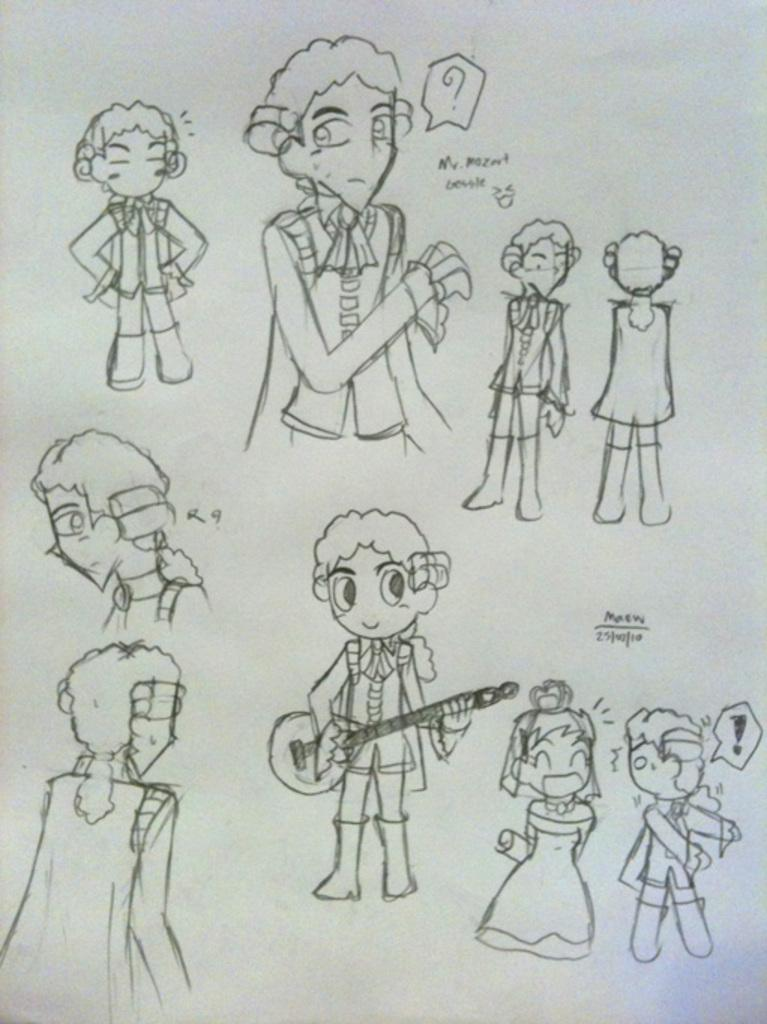What is depicted in the image? There is a drawing of persons in the image. What are the persons in the drawing doing? There is a person holding a musical instrument in the drawing. What else can be seen in the image besides the drawing? There is text and numbers in the image. What is the color of the background in the image? The background of the image is white in color. What type of transport can be seen in the image? There is no transport visible in the image; it features a drawing of persons and text. Is there a hat worn by any of the persons in the drawing? There is no hat visible on any of the persons in the drawing. 